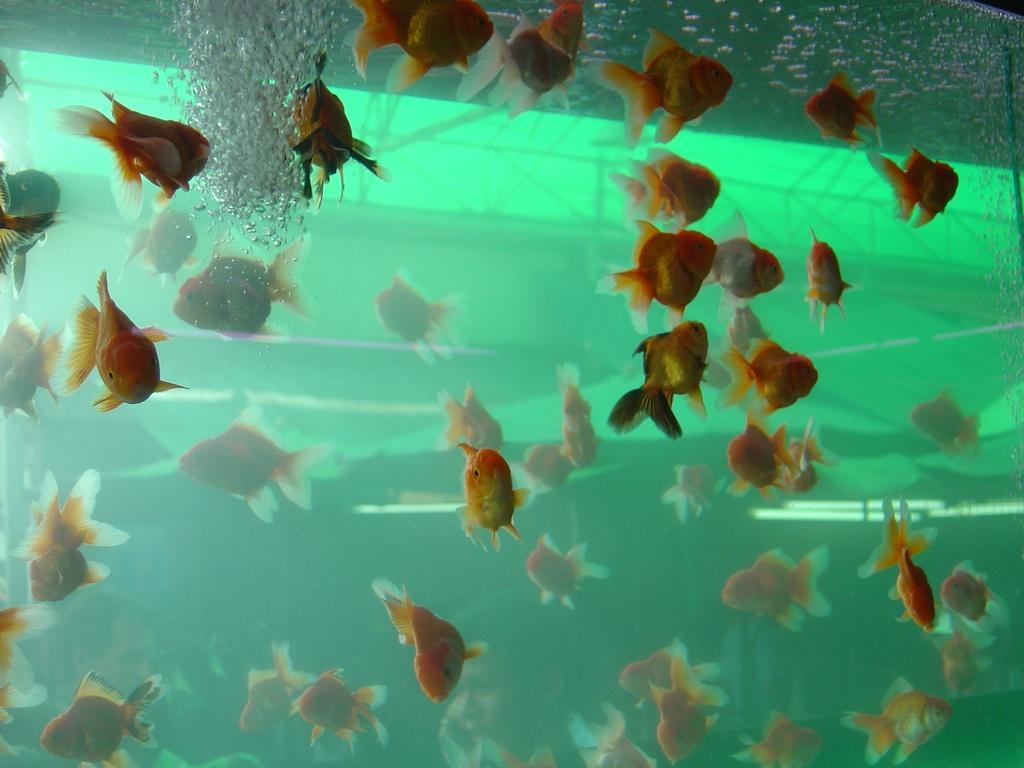Please provide a concise description of this image. In this image there are some fishes in the aquarium as we can see in the middle of this image. 